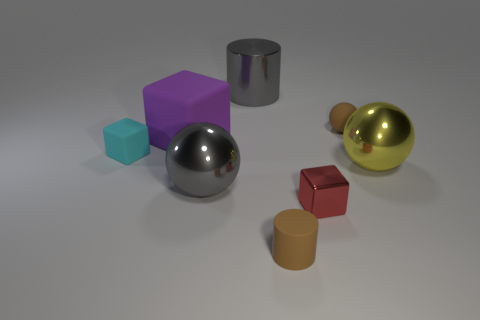There is a small cube behind the small red thing; what is it made of?
Provide a succinct answer. Rubber. What is the red object made of?
Offer a very short reply. Metal. What material is the large ball that is left of the tiny brown matte object that is behind the large gray thing in front of the brown ball?
Ensure brevity in your answer.  Metal. Are there any other things that have the same material as the large cylinder?
Provide a short and direct response. Yes. There is a red thing; does it have the same size as the gray thing behind the small cyan rubber object?
Provide a succinct answer. No. What number of objects are either small matte things in front of the tiny rubber block or large things that are left of the yellow sphere?
Your response must be concise. 4. There is a metallic ball that is on the right side of the tiny brown matte cylinder; what color is it?
Provide a short and direct response. Yellow. There is a big sphere that is to the right of the red metallic block; is there a tiny cube right of it?
Offer a very short reply. No. Are there fewer small rubber spheres than spheres?
Your answer should be very brief. Yes. There is a small block right of the brown thing in front of the large matte object; what is it made of?
Make the answer very short. Metal. 